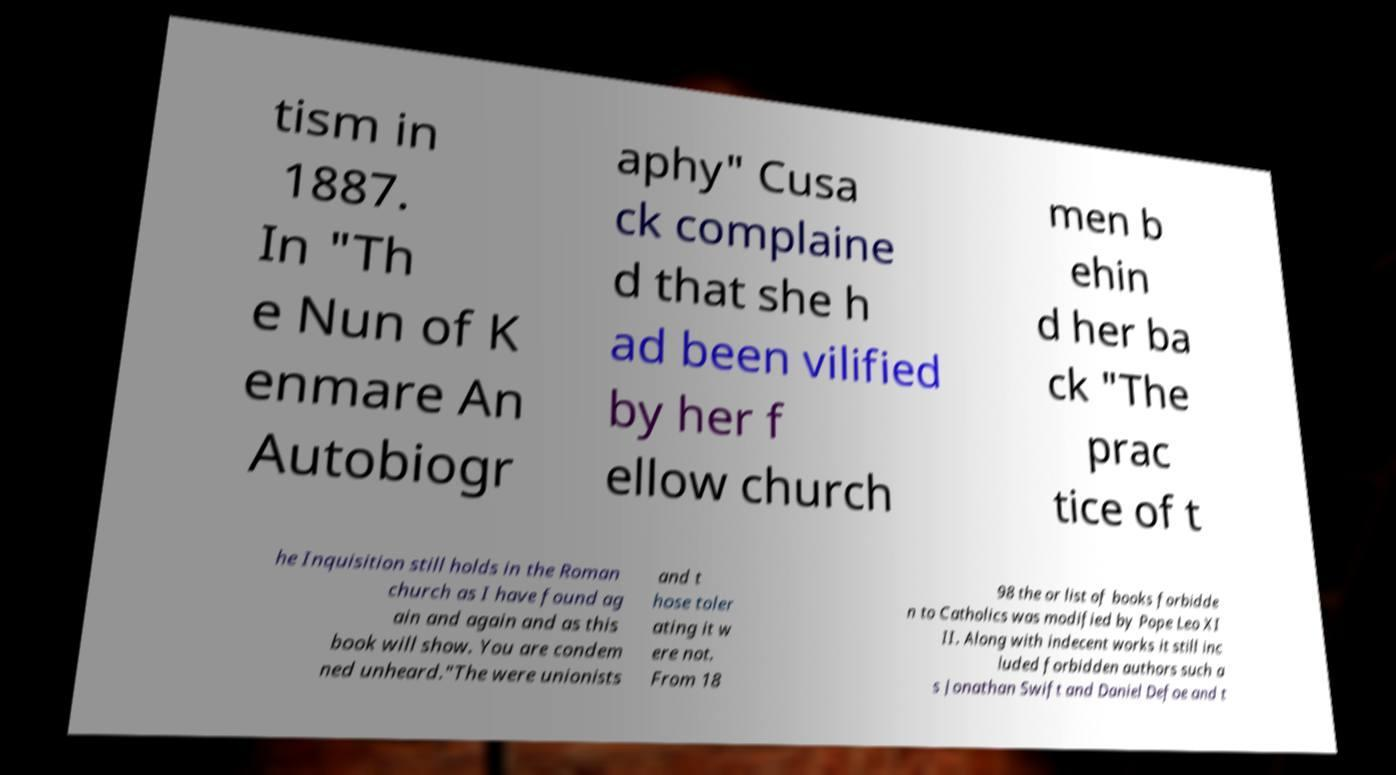There's text embedded in this image that I need extracted. Can you transcribe it verbatim? tism in 1887. In "Th e Nun of K enmare An Autobiogr aphy" Cusa ck complaine d that she h ad been vilified by her f ellow church men b ehin d her ba ck "The prac tice of t he Inquisition still holds in the Roman church as I have found ag ain and again and as this book will show. You are condem ned unheard."The were unionists and t hose toler ating it w ere not. From 18 98 the or list of books forbidde n to Catholics was modified by Pope Leo XI II. Along with indecent works it still inc luded forbidden authors such a s Jonathan Swift and Daniel Defoe and t 